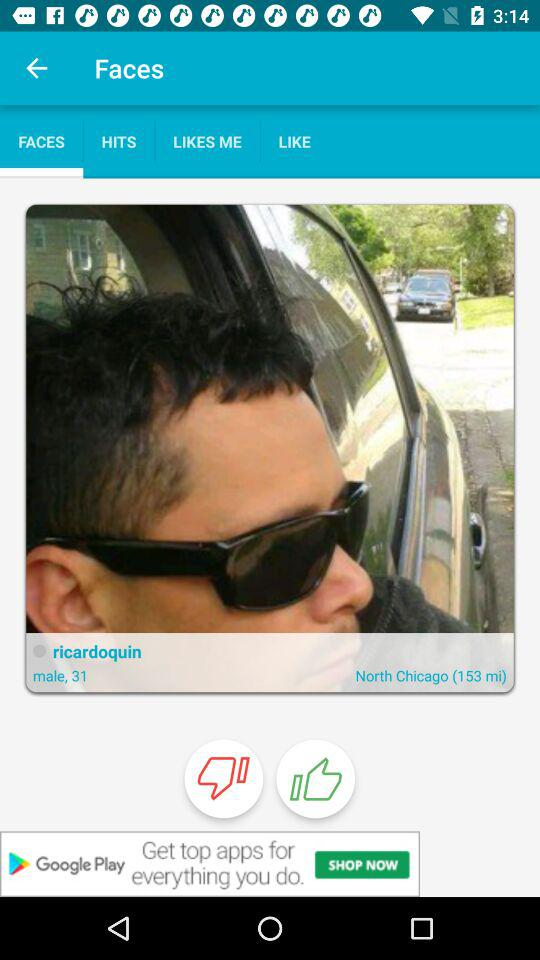What is the age of "ricardoquin"? The age of "ricardoquin" is 31. 